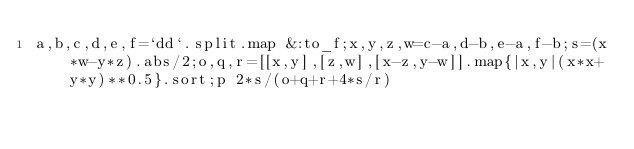Convert code to text. <code><loc_0><loc_0><loc_500><loc_500><_Ruby_>a,b,c,d,e,f=`dd`.split.map &:to_f;x,y,z,w=c-a,d-b,e-a,f-b;s=(x*w-y*z).abs/2;o,q,r=[[x,y],[z,w],[x-z,y-w]].map{|x,y|(x*x+y*y)**0.5}.sort;p 2*s/(o+q+r+4*s/r)</code> 